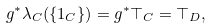<formula> <loc_0><loc_0><loc_500><loc_500>g ^ { \ast } \lambda _ { C } ( \{ 1 _ { C } \} ) = g ^ { \ast } \top _ { C } = \top _ { D } ,</formula> 